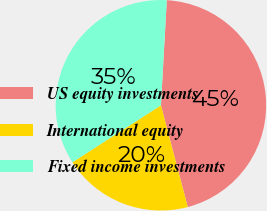Convert chart. <chart><loc_0><loc_0><loc_500><loc_500><pie_chart><fcel>US equity investments<fcel>International equity<fcel>Fixed income investments<nl><fcel>45.0%<fcel>20.0%<fcel>35.0%<nl></chart> 